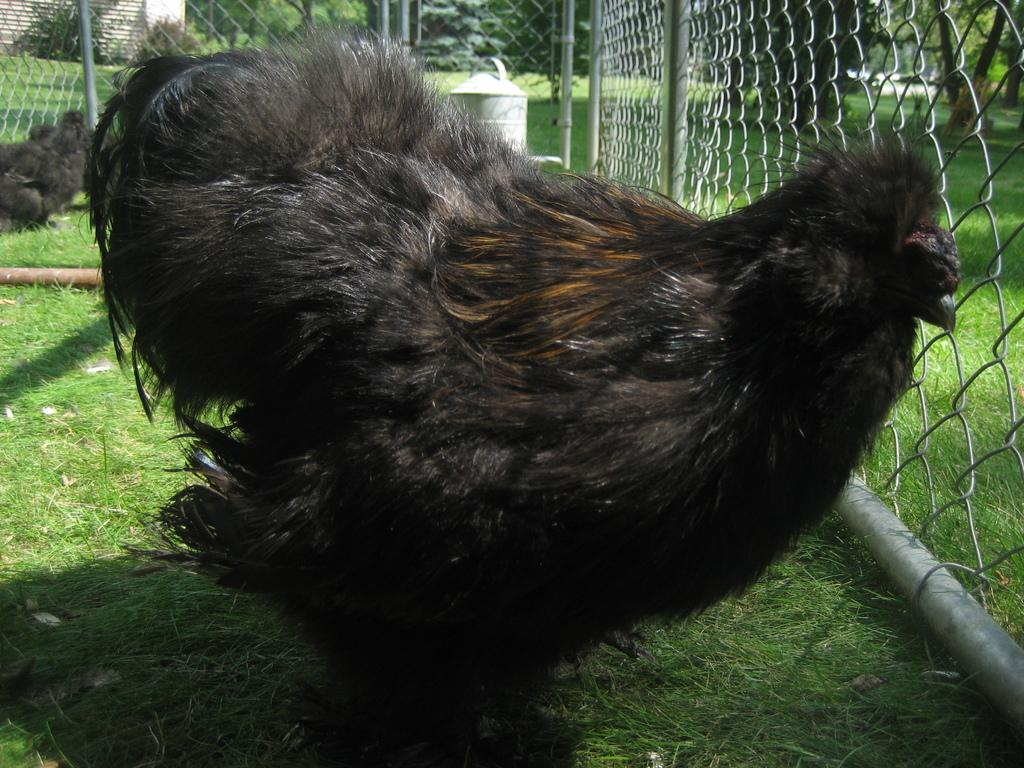What type of animals can be seen in the image? There are birds in the image. What is at the bottom of the image? There is grass at the bottom of the image. What is separating the grass from the background in the image? There is a fence in the image. What can be seen in the background of the image? There are trees and a wall in the background of the image. What type of apparel is the bird wearing in the image? There is no apparel present on the birds in the image, as birds do not wear clothing. 